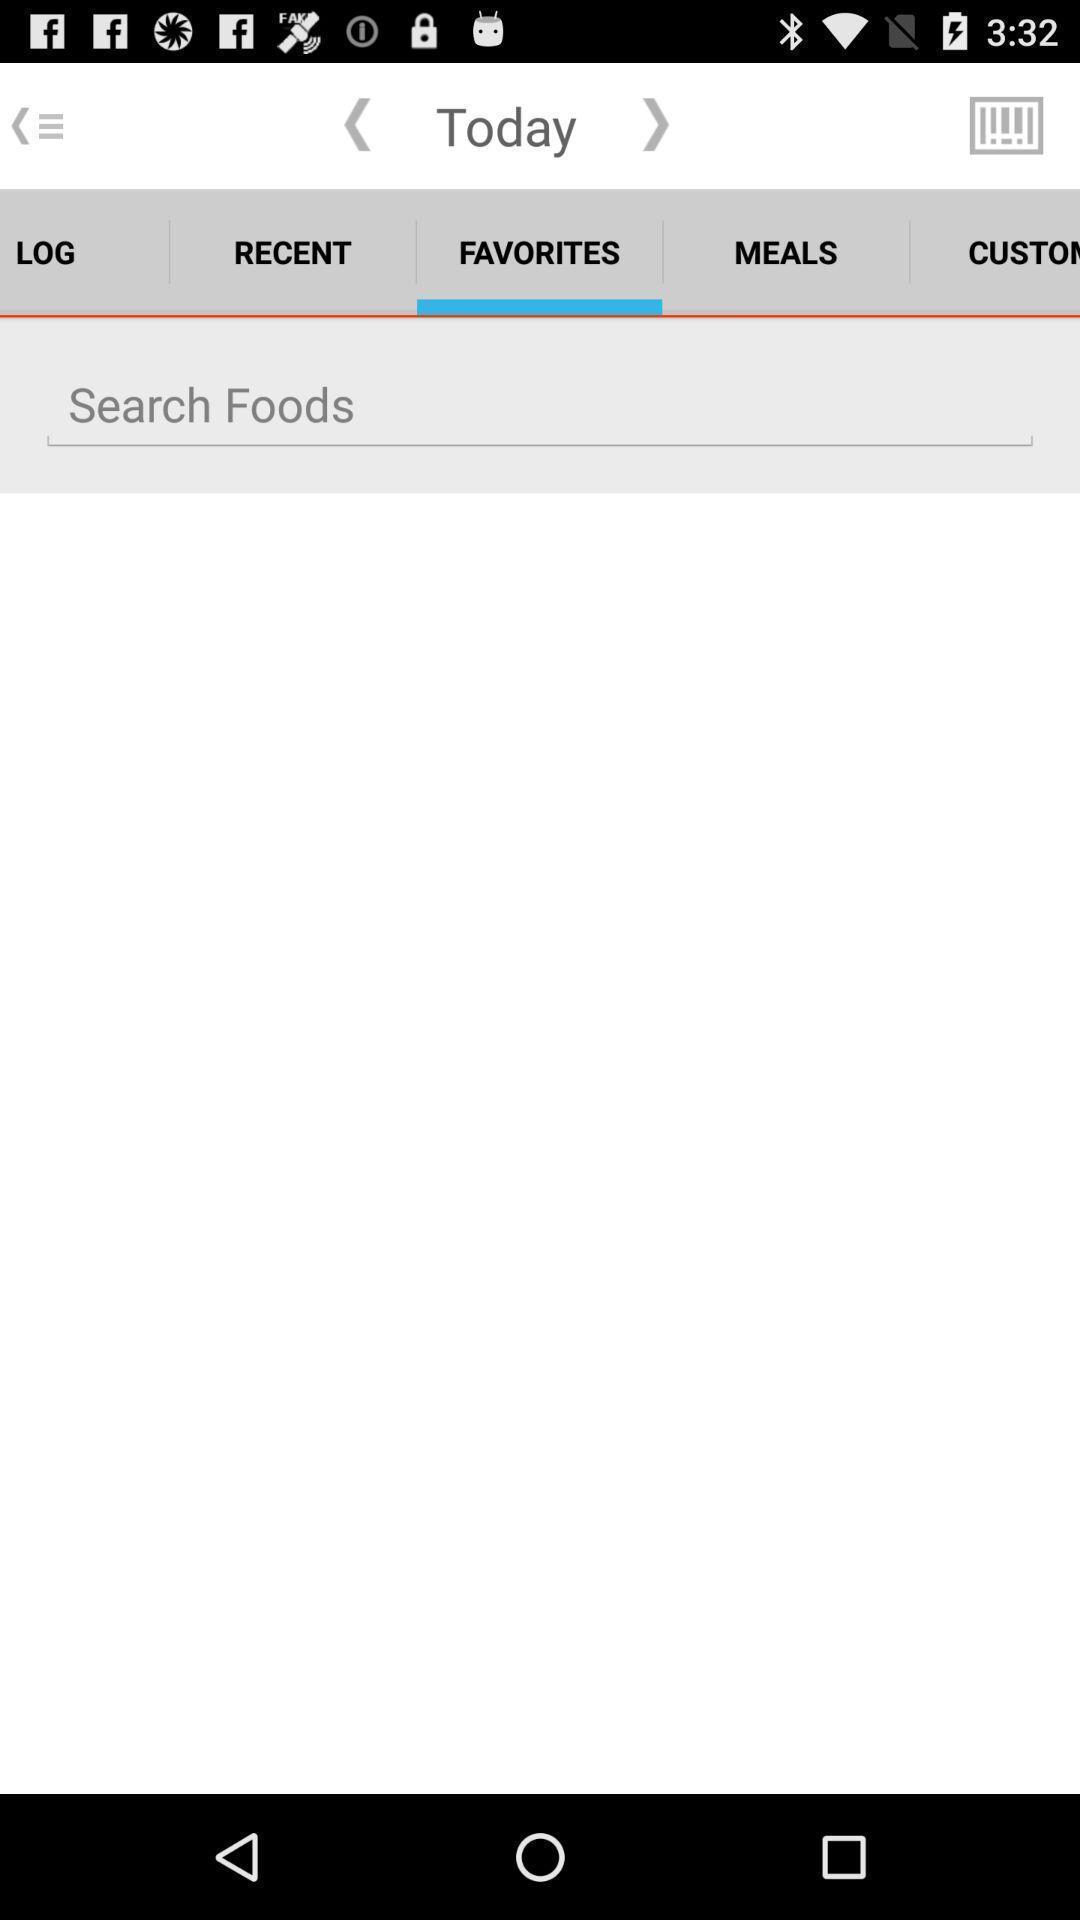Explain what's happening in this screen capture. Search option to find a food details. 